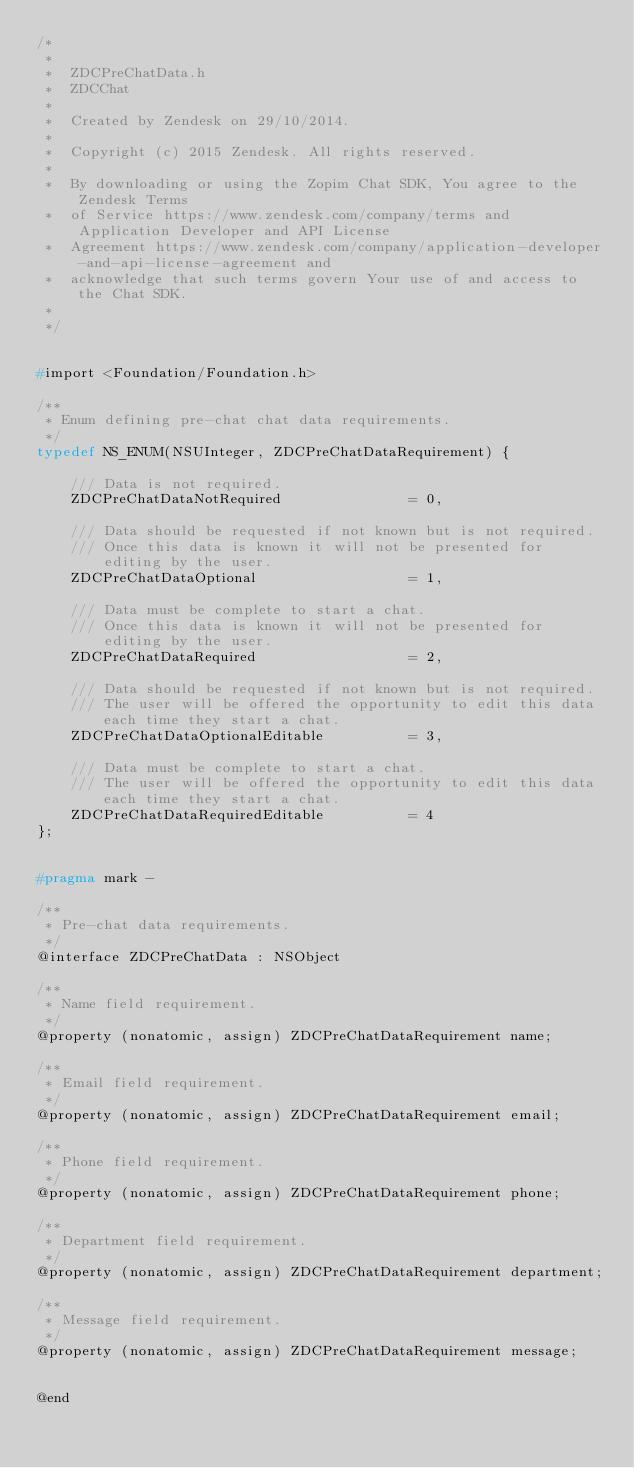<code> <loc_0><loc_0><loc_500><loc_500><_C_>/*
 *
 *  ZDCPreChatData.h
 *  ZDCChat
 *
 *  Created by Zendesk on 29/10/2014.
 *
 *  Copyright (c) 2015 Zendesk. All rights reserved.
 *
 *  By downloading or using the Zopim Chat SDK, You agree to the Zendesk Terms
 *  of Service https://www.zendesk.com/company/terms and Application Developer and API License
 *  Agreement https://www.zendesk.com/company/application-developer-and-api-license-agreement and
 *  acknowledge that such terms govern Your use of and access to the Chat SDK.
 *
 */


#import <Foundation/Foundation.h>

/**
 * Enum defining pre-chat chat data requirements.
 */
typedef NS_ENUM(NSUInteger, ZDCPreChatDataRequirement) {

    /// Data is not required.
    ZDCPreChatDataNotRequired               = 0,

    /// Data should be requested if not known but is not required.
    /// Once this data is known it will not be presented for editing by the user.
    ZDCPreChatDataOptional                  = 1,

    /// Data must be complete to start a chat.
    /// Once this data is known it will not be presented for editing by the user.
    ZDCPreChatDataRequired                  = 2,

    /// Data should be requested if not known but is not required.
    /// The user will be offered the opportunity to edit this data each time they start a chat.
    ZDCPreChatDataOptionalEditable          = 3,

    /// Data must be complete to start a chat.
    /// The user will be offered the opportunity to edit this data each time they start a chat.
    ZDCPreChatDataRequiredEditable          = 4
};


#pragma mark -

/**
 * Pre-chat data requirements.
 */
@interface ZDCPreChatData : NSObject

/**
 * Name field requirement.
 */
@property (nonatomic, assign) ZDCPreChatDataRequirement name;

/**
 * Email field requirement.
 */
@property (nonatomic, assign) ZDCPreChatDataRequirement email;

/**
 * Phone field requirement.
 */
@property (nonatomic, assign) ZDCPreChatDataRequirement phone;

/**
 * Department field requirement.
 */
@property (nonatomic, assign) ZDCPreChatDataRequirement department;

/**
 * Message field requirement.
 */
@property (nonatomic, assign) ZDCPreChatDataRequirement message;


@end
</code> 